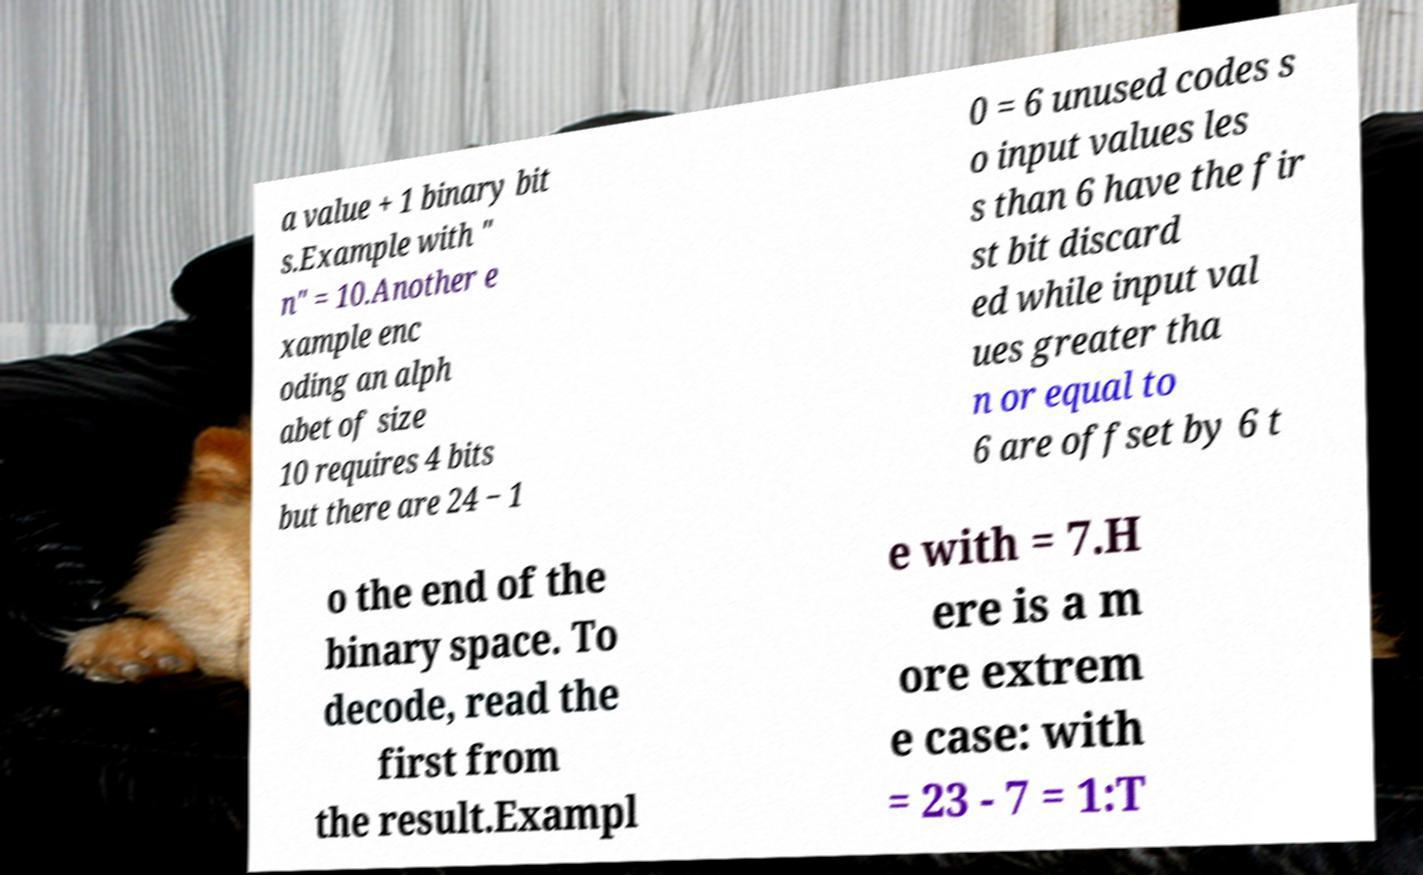Could you extract and type out the text from this image? a value + 1 binary bit s.Example with " n" = 10.Another e xample enc oding an alph abet of size 10 requires 4 bits but there are 24 − 1 0 = 6 unused codes s o input values les s than 6 have the fir st bit discard ed while input val ues greater tha n or equal to 6 are offset by 6 t o the end of the binary space. To decode, read the first from the result.Exampl e with = 7.H ere is a m ore extrem e case: with = 23 - 7 = 1:T 